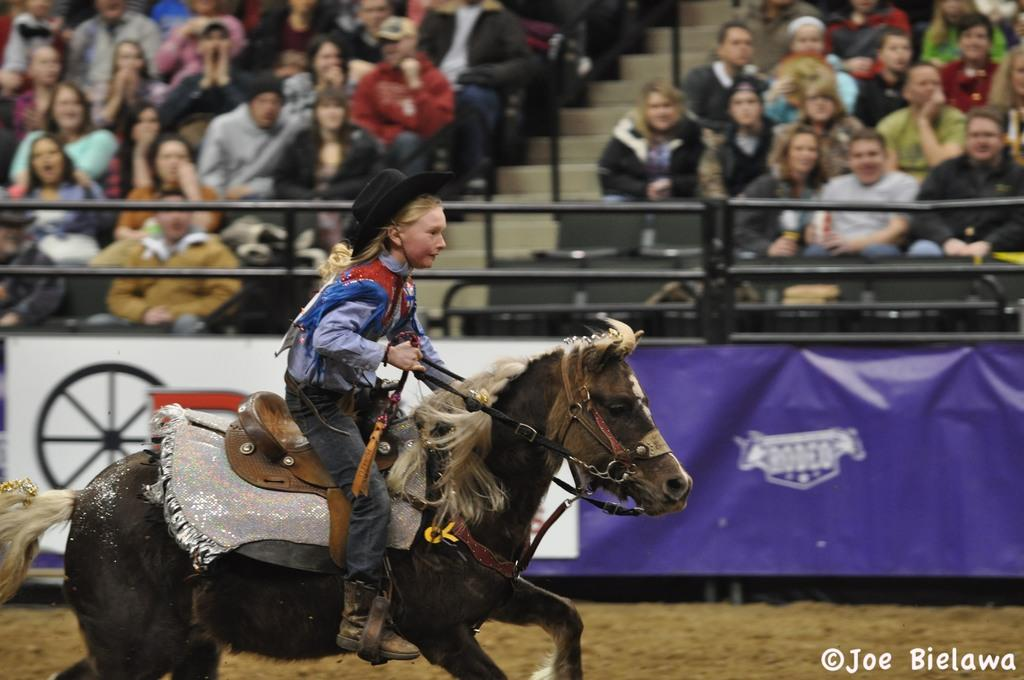What are the people in the image doing? There is a group of people sitting on chairs, while another person is riding a horse. Can you describe the person riding the horse? The person riding the horse is wearing a hat. What architectural feature can be seen in the image? There are steps in the image. What objects are present in the image that resemble long, thin bars? There are rods in the image. What type of signage is visible in the image? There is a banner in the image. What type of terrain is visible in the image? There is sand visible in the image. What type of cookware is being used to cook apples in the image? There is no cookware or apples present in the image. What is the zinc content of the sand visible in the image? The zinc content of the sand cannot be determined from the image. 